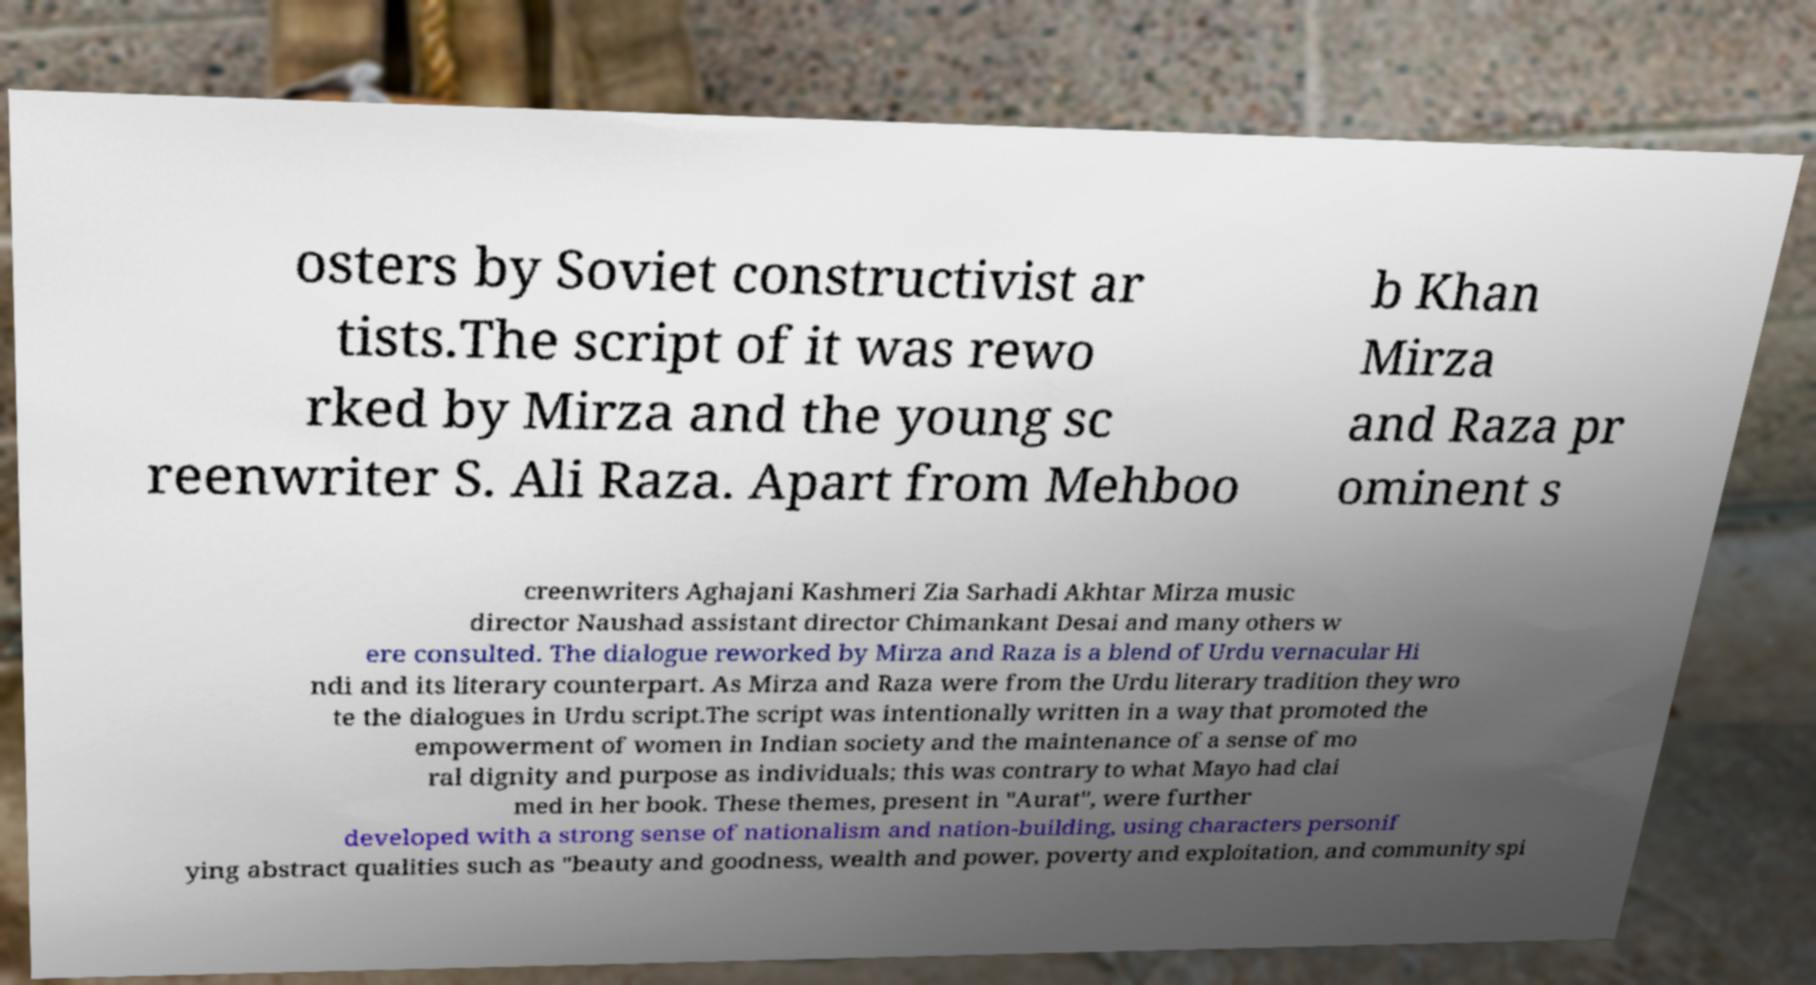Please identify and transcribe the text found in this image. osters by Soviet constructivist ar tists.The script of it was rewo rked by Mirza and the young sc reenwriter S. Ali Raza. Apart from Mehboo b Khan Mirza and Raza pr ominent s creenwriters Aghajani Kashmeri Zia Sarhadi Akhtar Mirza music director Naushad assistant director Chimankant Desai and many others w ere consulted. The dialogue reworked by Mirza and Raza is a blend of Urdu vernacular Hi ndi and its literary counterpart. As Mirza and Raza were from the Urdu literary tradition they wro te the dialogues in Urdu script.The script was intentionally written in a way that promoted the empowerment of women in Indian society and the maintenance of a sense of mo ral dignity and purpose as individuals; this was contrary to what Mayo had clai med in her book. These themes, present in "Aurat", were further developed with a strong sense of nationalism and nation-building, using characters personif ying abstract qualities such as "beauty and goodness, wealth and power, poverty and exploitation, and community spi 